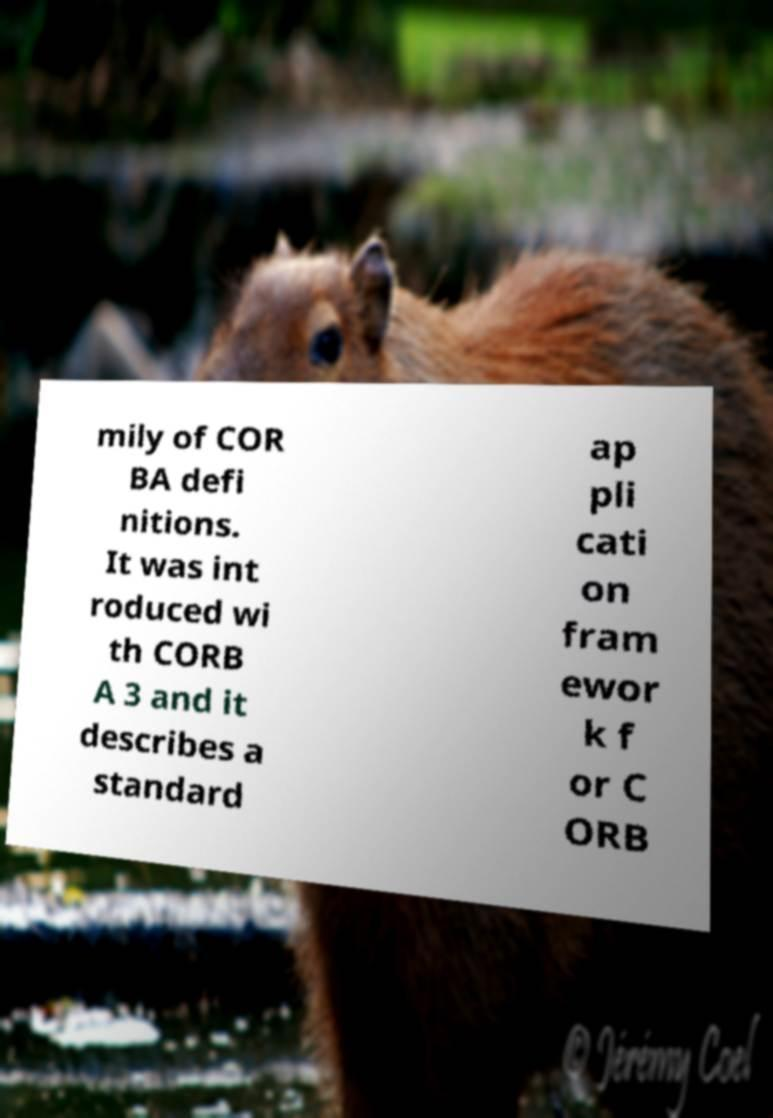Please read and relay the text visible in this image. What does it say? mily of COR BA defi nitions. It was int roduced wi th CORB A 3 and it describes a standard ap pli cati on fram ewor k f or C ORB 